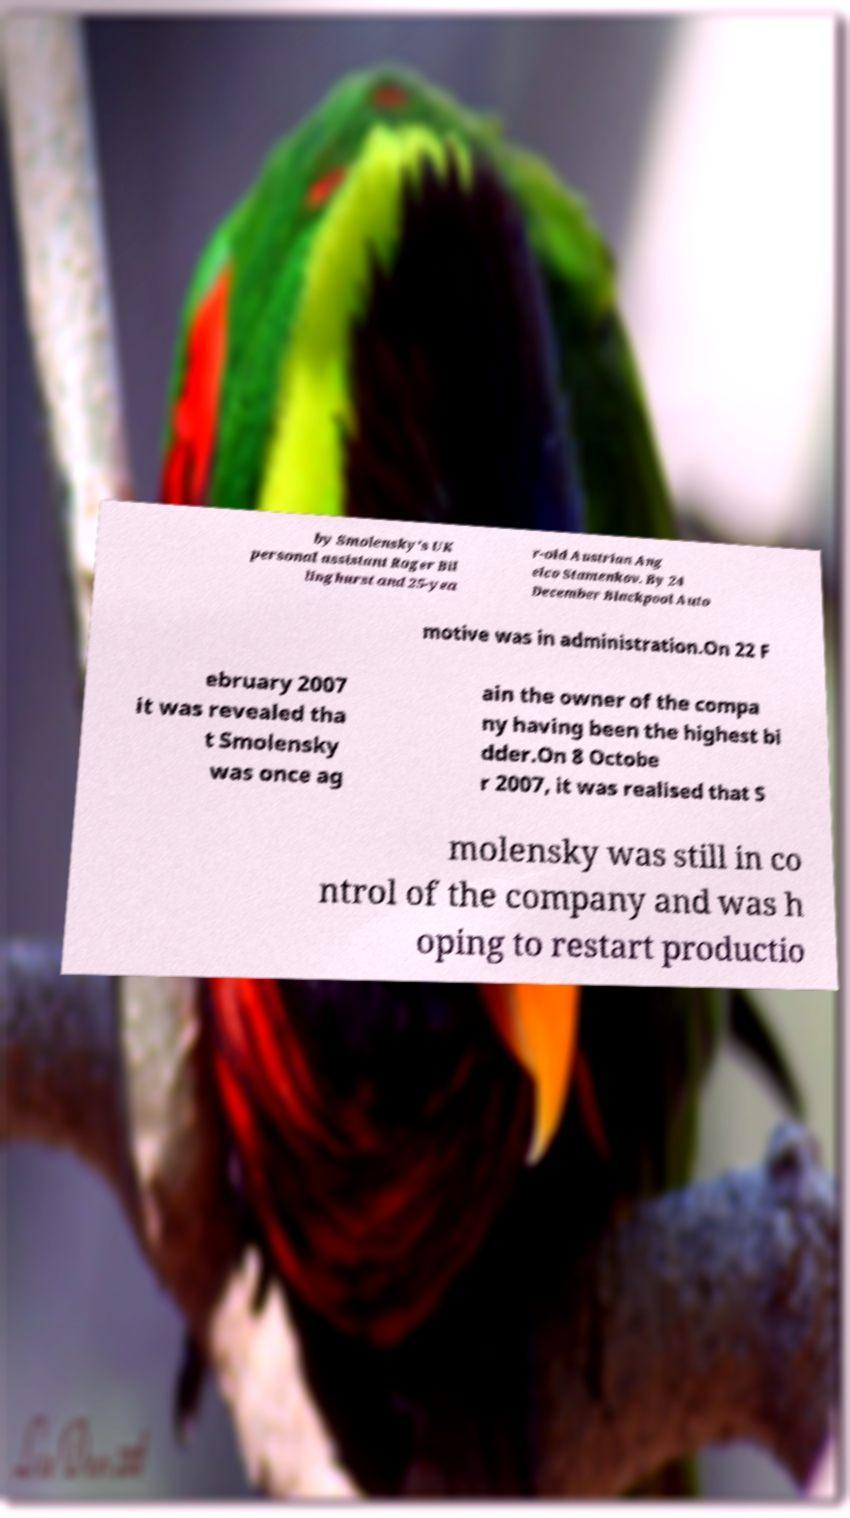I need the written content from this picture converted into text. Can you do that? by Smolensky's UK personal assistant Roger Bil linghurst and 25-yea r-old Austrian Ang elco Stamenkov. By 24 December Blackpool Auto motive was in administration.On 22 F ebruary 2007 it was revealed tha t Smolensky was once ag ain the owner of the compa ny having been the highest bi dder.On 8 Octobe r 2007, it was realised that S molensky was still in co ntrol of the company and was h oping to restart productio 